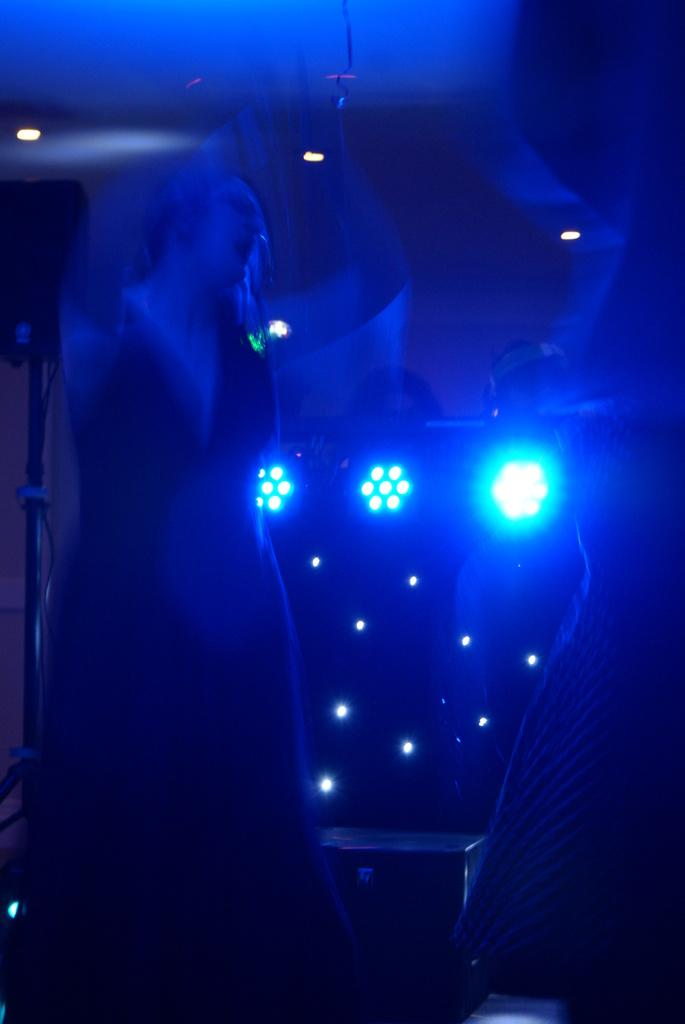What is the main subject of the image? There is a person standing in the image. What can be seen in the background of the image? There are focus lights and other objects visible in the background of the image. What type of whip is being used by the person in the image? There is no whip present in the image; it only features a person standing and objects in the background. 